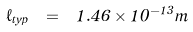<formula> <loc_0><loc_0><loc_500><loc_500>\ell _ { t y p } \ = \ 1 . 4 6 \times 1 0 ^ { - 1 3 } m</formula> 